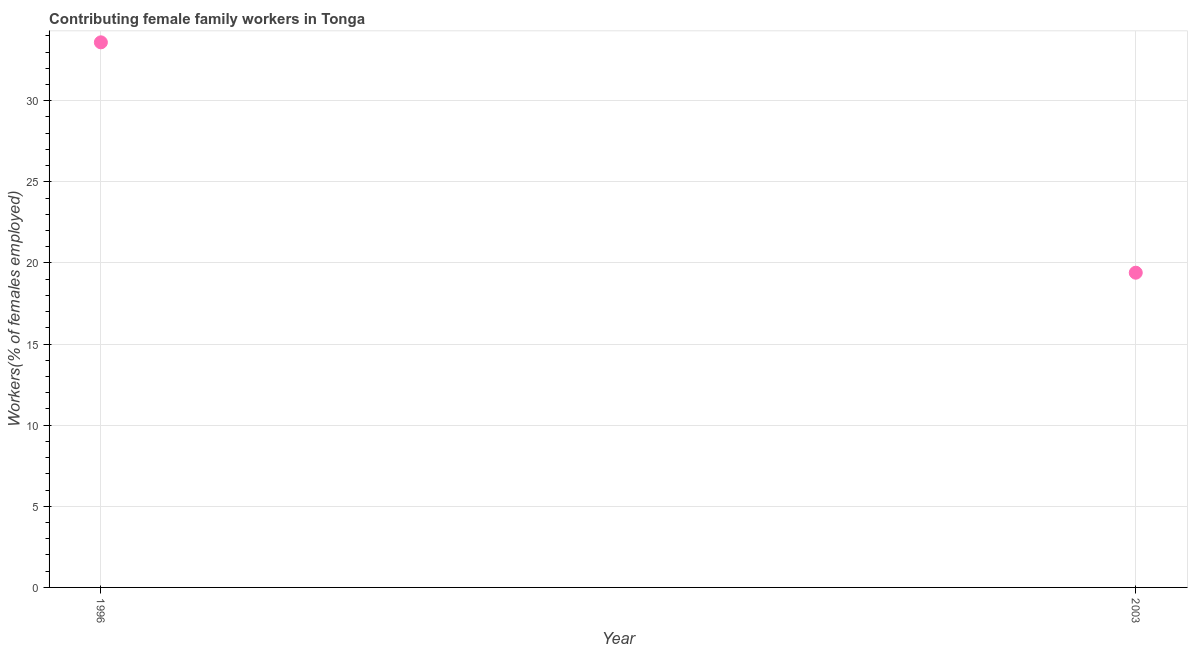What is the contributing female family workers in 1996?
Keep it short and to the point. 33.6. Across all years, what is the maximum contributing female family workers?
Your response must be concise. 33.6. Across all years, what is the minimum contributing female family workers?
Keep it short and to the point. 19.4. What is the sum of the contributing female family workers?
Provide a short and direct response. 53. What is the difference between the contributing female family workers in 1996 and 2003?
Your answer should be very brief. 14.2. What is the average contributing female family workers per year?
Offer a very short reply. 26.5. What is the median contributing female family workers?
Give a very brief answer. 26.5. In how many years, is the contributing female family workers greater than 15 %?
Your answer should be very brief. 2. Do a majority of the years between 1996 and 2003 (inclusive) have contributing female family workers greater than 25 %?
Ensure brevity in your answer.  No. What is the ratio of the contributing female family workers in 1996 to that in 2003?
Ensure brevity in your answer.  1.73. Is the contributing female family workers in 1996 less than that in 2003?
Ensure brevity in your answer.  No. In how many years, is the contributing female family workers greater than the average contributing female family workers taken over all years?
Ensure brevity in your answer.  1. Does the contributing female family workers monotonically increase over the years?
Make the answer very short. No. What is the difference between two consecutive major ticks on the Y-axis?
Offer a very short reply. 5. Does the graph contain grids?
Provide a succinct answer. Yes. What is the title of the graph?
Offer a terse response. Contributing female family workers in Tonga. What is the label or title of the X-axis?
Your response must be concise. Year. What is the label or title of the Y-axis?
Your answer should be compact. Workers(% of females employed). What is the Workers(% of females employed) in 1996?
Keep it short and to the point. 33.6. What is the Workers(% of females employed) in 2003?
Keep it short and to the point. 19.4. What is the difference between the Workers(% of females employed) in 1996 and 2003?
Offer a very short reply. 14.2. What is the ratio of the Workers(% of females employed) in 1996 to that in 2003?
Your response must be concise. 1.73. 